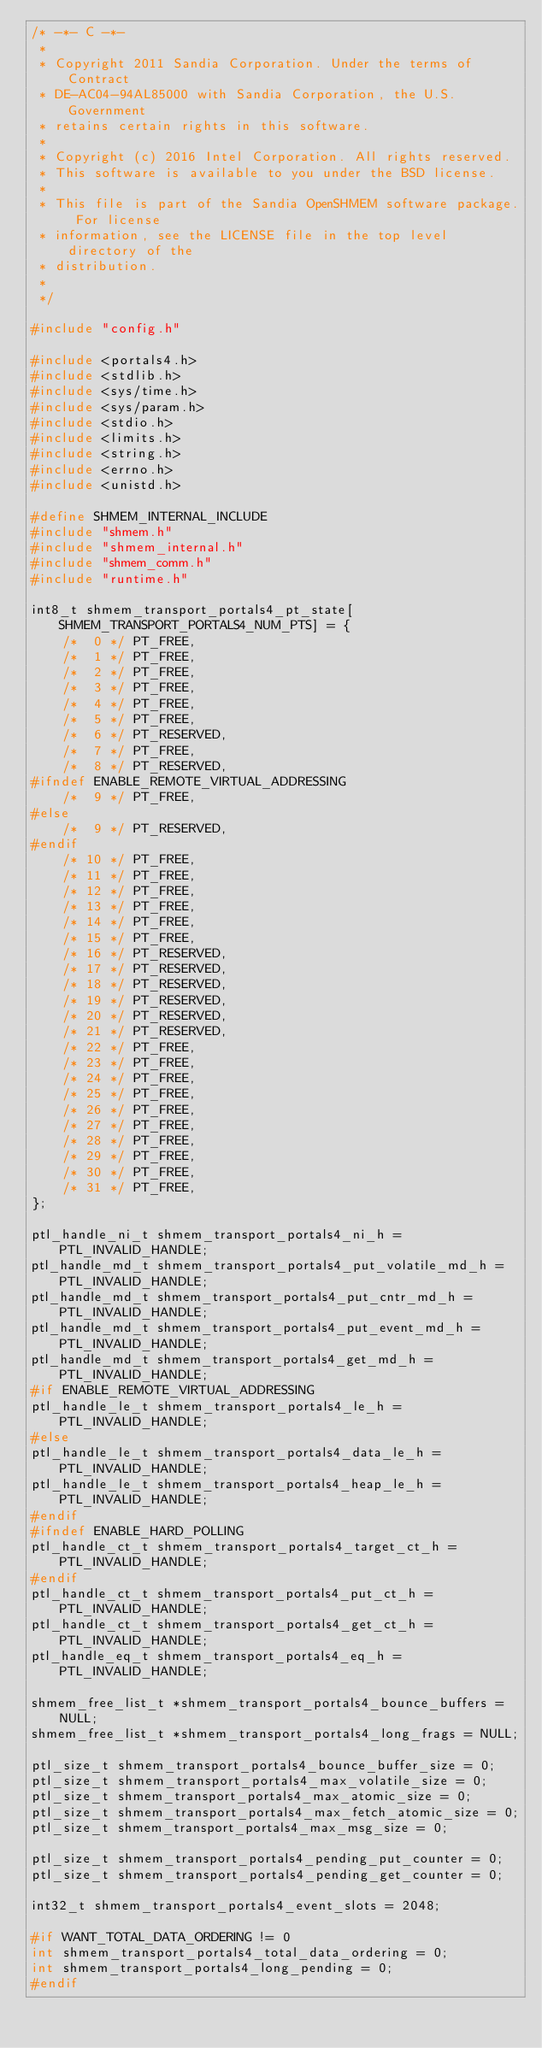<code> <loc_0><loc_0><loc_500><loc_500><_C_>/* -*- C -*-
 *
 * Copyright 2011 Sandia Corporation. Under the terms of Contract
 * DE-AC04-94AL85000 with Sandia Corporation, the U.S.  Government
 * retains certain rights in this software.
 *
 * Copyright (c) 2016 Intel Corporation. All rights reserved.
 * This software is available to you under the BSD license.
 *
 * This file is part of the Sandia OpenSHMEM software package. For license
 * information, see the LICENSE file in the top level directory of the
 * distribution.
 *
 */

#include "config.h"

#include <portals4.h>
#include <stdlib.h>
#include <sys/time.h>
#include <sys/param.h>
#include <stdio.h>
#include <limits.h>
#include <string.h>
#include <errno.h>
#include <unistd.h>

#define SHMEM_INTERNAL_INCLUDE
#include "shmem.h"
#include "shmem_internal.h"
#include "shmem_comm.h"
#include "runtime.h"

int8_t shmem_transport_portals4_pt_state[SHMEM_TRANSPORT_PORTALS4_NUM_PTS] = {
    /*  0 */ PT_FREE,
    /*  1 */ PT_FREE,
    /*  2 */ PT_FREE,
    /*  3 */ PT_FREE,
    /*  4 */ PT_FREE,
    /*  5 */ PT_FREE,
    /*  6 */ PT_RESERVED,
    /*  7 */ PT_FREE,
    /*  8 */ PT_RESERVED,
#ifndef ENABLE_REMOTE_VIRTUAL_ADDRESSING
    /*  9 */ PT_FREE,
#else
    /*  9 */ PT_RESERVED,
#endif
    /* 10 */ PT_FREE,
    /* 11 */ PT_FREE,
    /* 12 */ PT_FREE,
    /* 13 */ PT_FREE,
    /* 14 */ PT_FREE,
    /* 15 */ PT_FREE,
    /* 16 */ PT_RESERVED,
    /* 17 */ PT_RESERVED,
    /* 18 */ PT_RESERVED,
    /* 19 */ PT_RESERVED,
    /* 20 */ PT_RESERVED,
    /* 21 */ PT_RESERVED,
    /* 22 */ PT_FREE,
    /* 23 */ PT_FREE,
    /* 24 */ PT_FREE,
    /* 25 */ PT_FREE,
    /* 26 */ PT_FREE,
    /* 27 */ PT_FREE,
    /* 28 */ PT_FREE,
    /* 29 */ PT_FREE,
    /* 30 */ PT_FREE,
    /* 31 */ PT_FREE,
};

ptl_handle_ni_t shmem_transport_portals4_ni_h = PTL_INVALID_HANDLE;
ptl_handle_md_t shmem_transport_portals4_put_volatile_md_h = PTL_INVALID_HANDLE;
ptl_handle_md_t shmem_transport_portals4_put_cntr_md_h = PTL_INVALID_HANDLE;
ptl_handle_md_t shmem_transport_portals4_put_event_md_h = PTL_INVALID_HANDLE;
ptl_handle_md_t shmem_transport_portals4_get_md_h = PTL_INVALID_HANDLE;
#if ENABLE_REMOTE_VIRTUAL_ADDRESSING
ptl_handle_le_t shmem_transport_portals4_le_h = PTL_INVALID_HANDLE;
#else
ptl_handle_le_t shmem_transport_portals4_data_le_h = PTL_INVALID_HANDLE;
ptl_handle_le_t shmem_transport_portals4_heap_le_h = PTL_INVALID_HANDLE;
#endif
#ifndef ENABLE_HARD_POLLING
ptl_handle_ct_t shmem_transport_portals4_target_ct_h = PTL_INVALID_HANDLE;
#endif
ptl_handle_ct_t shmem_transport_portals4_put_ct_h = PTL_INVALID_HANDLE;
ptl_handle_ct_t shmem_transport_portals4_get_ct_h = PTL_INVALID_HANDLE;
ptl_handle_eq_t shmem_transport_portals4_eq_h = PTL_INVALID_HANDLE;

shmem_free_list_t *shmem_transport_portals4_bounce_buffers = NULL;
shmem_free_list_t *shmem_transport_portals4_long_frags = NULL;

ptl_size_t shmem_transport_portals4_bounce_buffer_size = 0;
ptl_size_t shmem_transport_portals4_max_volatile_size = 0;
ptl_size_t shmem_transport_portals4_max_atomic_size = 0;
ptl_size_t shmem_transport_portals4_max_fetch_atomic_size = 0;
ptl_size_t shmem_transport_portals4_max_msg_size = 0;

ptl_size_t shmem_transport_portals4_pending_put_counter = 0;
ptl_size_t shmem_transport_portals4_pending_get_counter = 0;

int32_t shmem_transport_portals4_event_slots = 2048;

#if WANT_TOTAL_DATA_ORDERING != 0
int shmem_transport_portals4_total_data_ordering = 0;
int shmem_transport_portals4_long_pending = 0;
#endif
</code> 